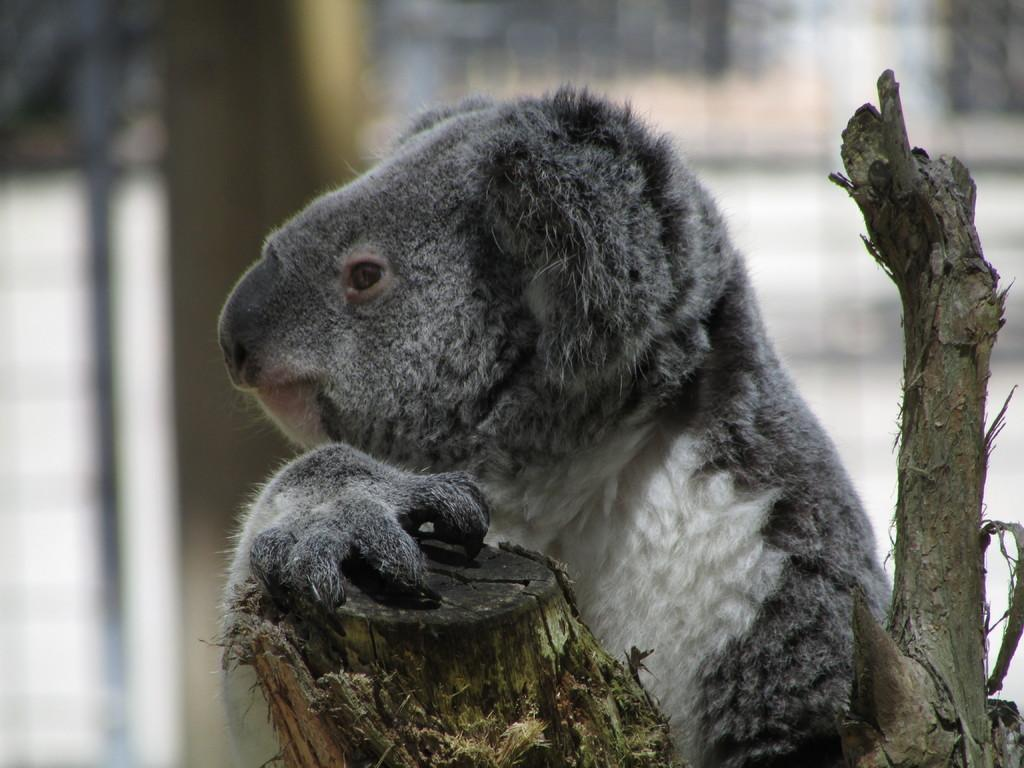What is the main subject in the image? There is a tree trunk in the image. What animal can be seen behind the tree trunk? There is a koala behind the tree trunk. What colors does the koala have? The koala is in grey and white color. How would you describe the background of the image? The background of the image is blurred. What type of marble is visible in the image? There is no marble present in the image. How does the koala attempt to stay cool in the heat? The image does not show the koala attempting to stay cool, nor does it depict any heat. 